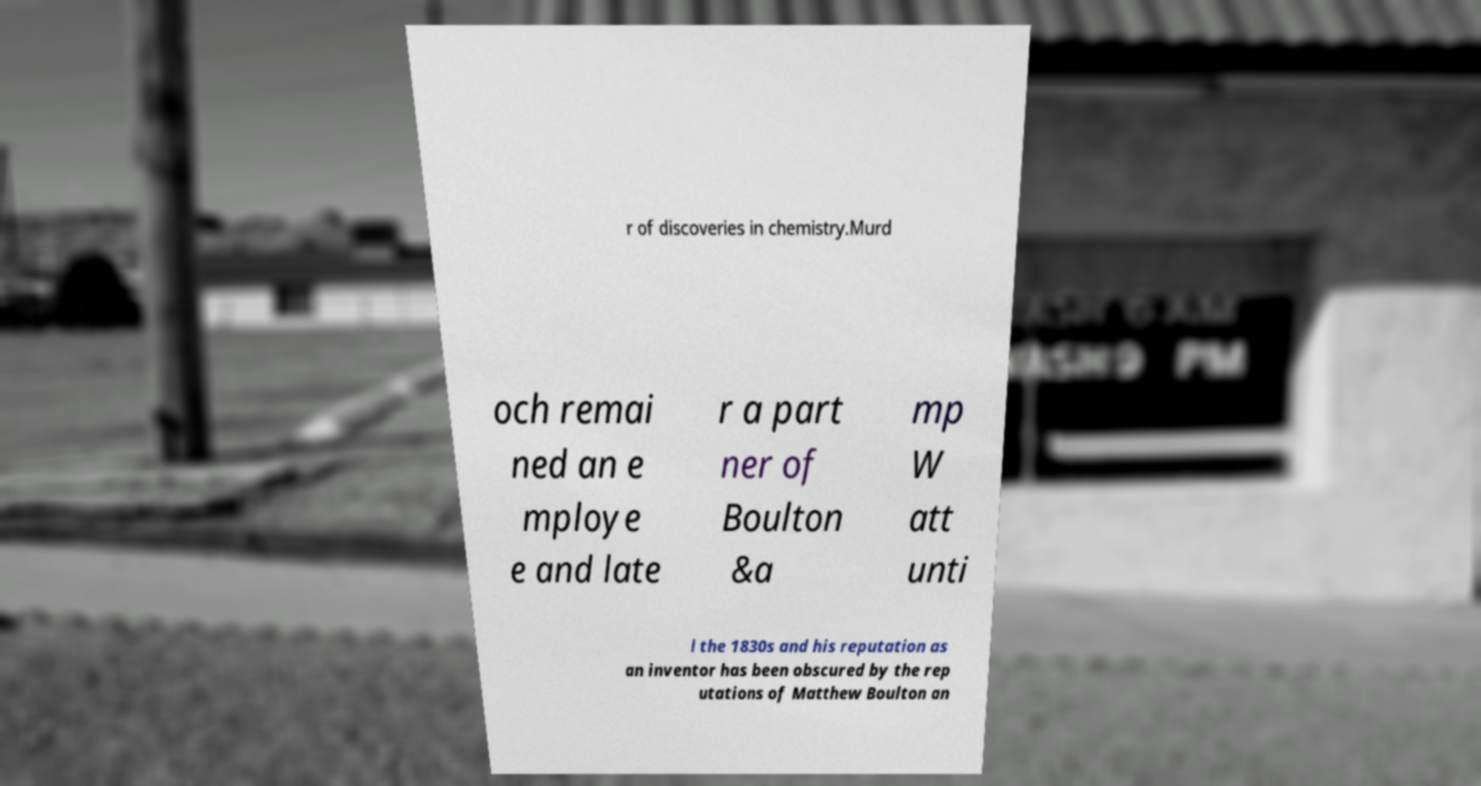I need the written content from this picture converted into text. Can you do that? r of discoveries in chemistry.Murd och remai ned an e mploye e and late r a part ner of Boulton &a mp W att unti l the 1830s and his reputation as an inventor has been obscured by the rep utations of Matthew Boulton an 